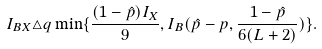<formula> <loc_0><loc_0><loc_500><loc_500>I _ { B X } \triangle q \min \{ \frac { ( 1 - \hat { p } ) I _ { X } } { 9 } , I _ { B } ( \hat { p } - p , \frac { 1 - \hat { p } } { 6 ( L + 2 ) } ) \} .</formula> 